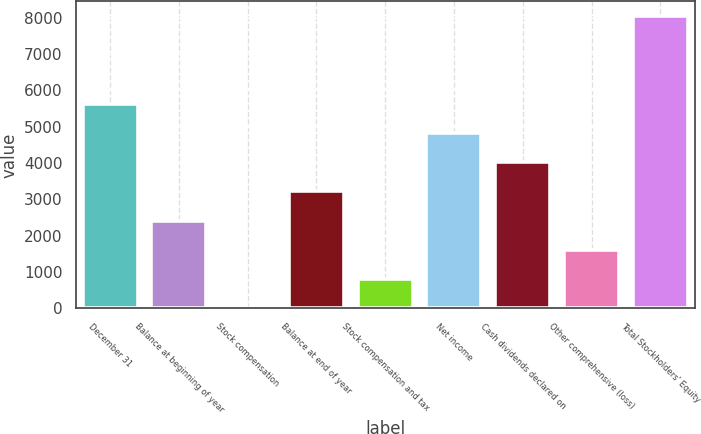<chart> <loc_0><loc_0><loc_500><loc_500><bar_chart><fcel>December 31<fcel>Balance at beginning of year<fcel>Stock compensation<fcel>Balance at end of year<fcel>Stock compensation and tax<fcel>Net income<fcel>Cash dividends declared on<fcel>Other comprehensive (loss)<fcel>Total Stockholders' Equity<nl><fcel>5635.68<fcel>2415.92<fcel>1.1<fcel>3220.86<fcel>806.04<fcel>4830.74<fcel>4025.8<fcel>1610.98<fcel>8050.5<nl></chart> 